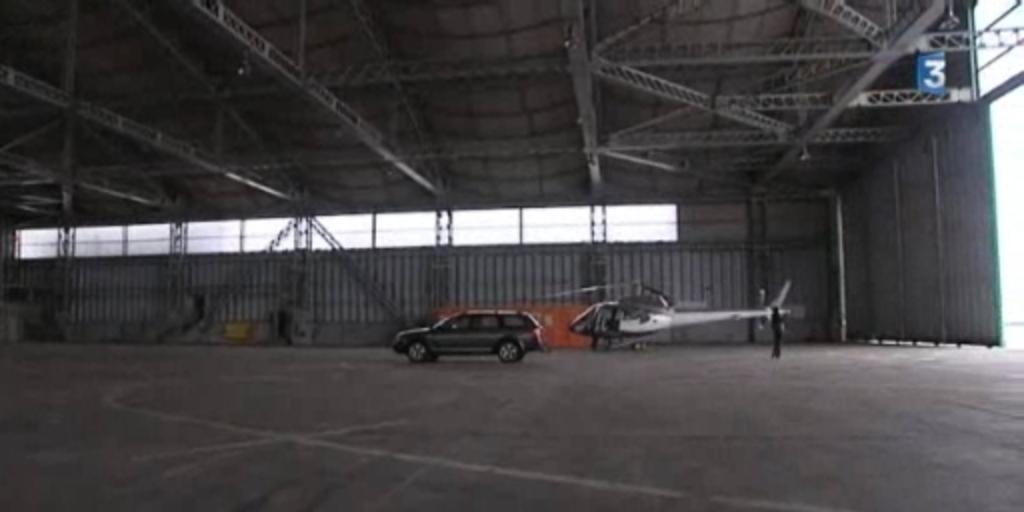<image>
Describe the image concisely. A large empty warehouse is identified with a blue flag bearing a number 3 on it. 